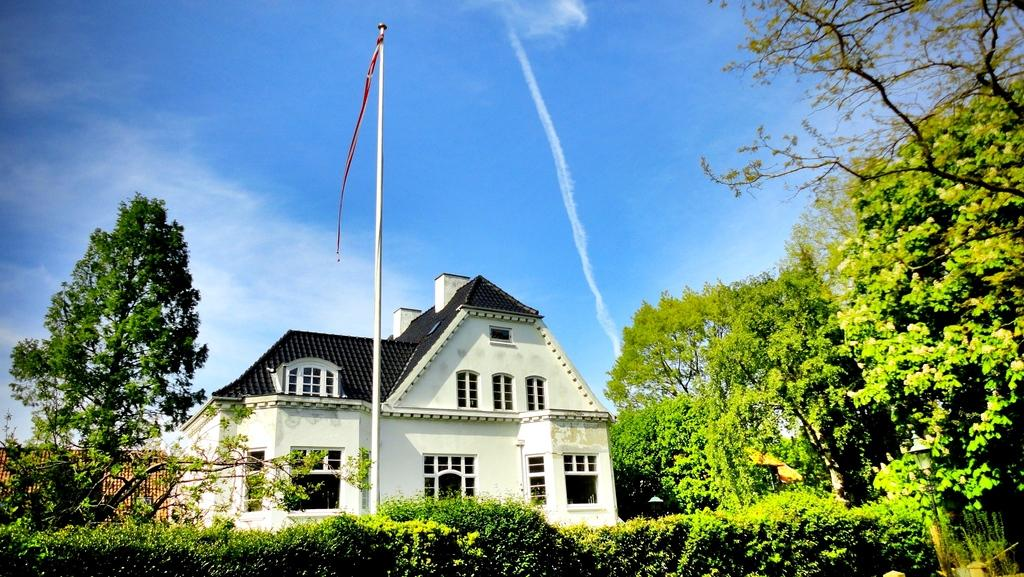What type of structure is present in the image? There is a building in the image. What other natural elements can be seen in the image? There are trees in the image. Is there any man-made object that stands out in the image? Yes, there is a flagpole in the image. How would you describe the weather in the image? The sky is blue and cloudy in the image, suggesting a partly cloudy day. Can you see any harbors or boats in the image? There is no harbor or boat visible in the image. Are there any nuts or nut-related objects in the image? There are no nuts or nut-related objects present in the image. 